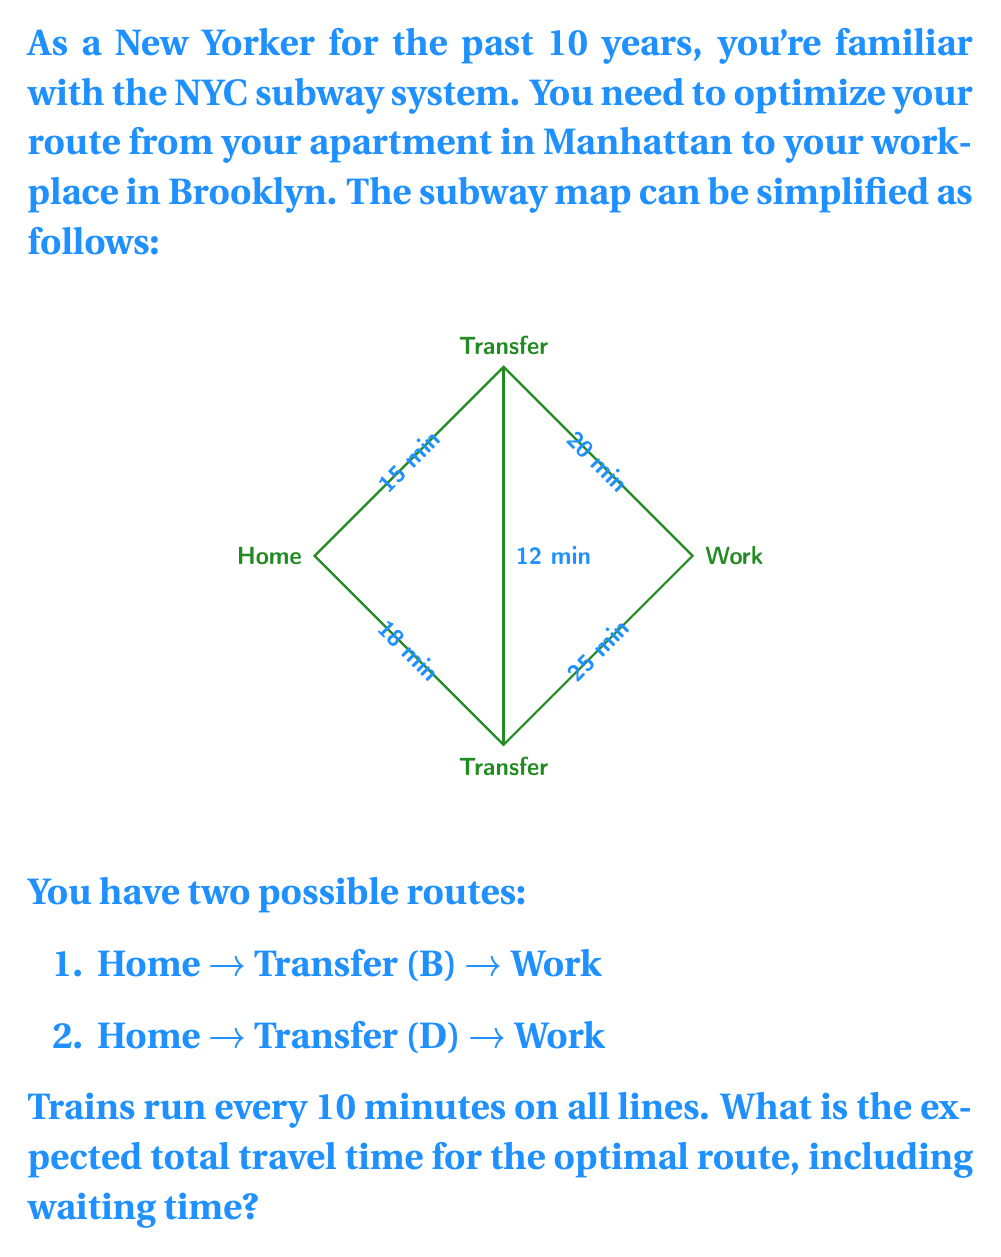Show me your answer to this math problem. Let's approach this step-by-step:

1) First, we need to calculate the expected waiting time. Since trains run every 10 minutes, the average waiting time is half of that: 5 minutes.

2) Now, let's calculate the total time for each route:

   Route 1: Home → Transfer (B) → Work
   - Expected waiting time at Home: 5 minutes
   - Travel time Home to B: 15 minutes
   - Expected waiting time at B: 5 minutes
   - Travel time B to Work: 20 minutes
   Total: $5 + 15 + 5 + 20 = 45$ minutes

   Route 2: Home → Transfer (D) → Work
   - Expected waiting time at Home: 5 minutes
   - Travel time Home to D: 18 minutes
   - Expected waiting time at D: 5 minutes
   - Travel time D to Work: 25 minutes
   Total: $5 + 18 + 5 + 25 = 53$ minutes

3) The optimal route is the one with the shorter total time, which is Route 1.

4) Therefore, the expected total travel time for the optimal route is 45 minutes.

We can express this mathematically as:

$$T_{optimal} = \min\left\{\sum_{i=1}^{n} (w_i + t_i)\right\}$$

Where $T_{optimal}$ is the optimal travel time, $w_i$ is the waiting time at each station, and $t_i$ is the travel time between stations.
Answer: 45 minutes 